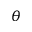Convert formula to latex. <formula><loc_0><loc_0><loc_500><loc_500>\theta</formula> 